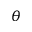Convert formula to latex. <formula><loc_0><loc_0><loc_500><loc_500>\theta</formula> 